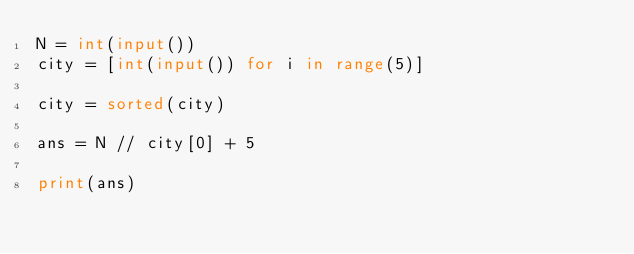Convert code to text. <code><loc_0><loc_0><loc_500><loc_500><_Python_>N = int(input())
city = [int(input()) for i in range(5)]

city = sorted(city)

ans = N // city[0] + 5
    
print(ans)</code> 